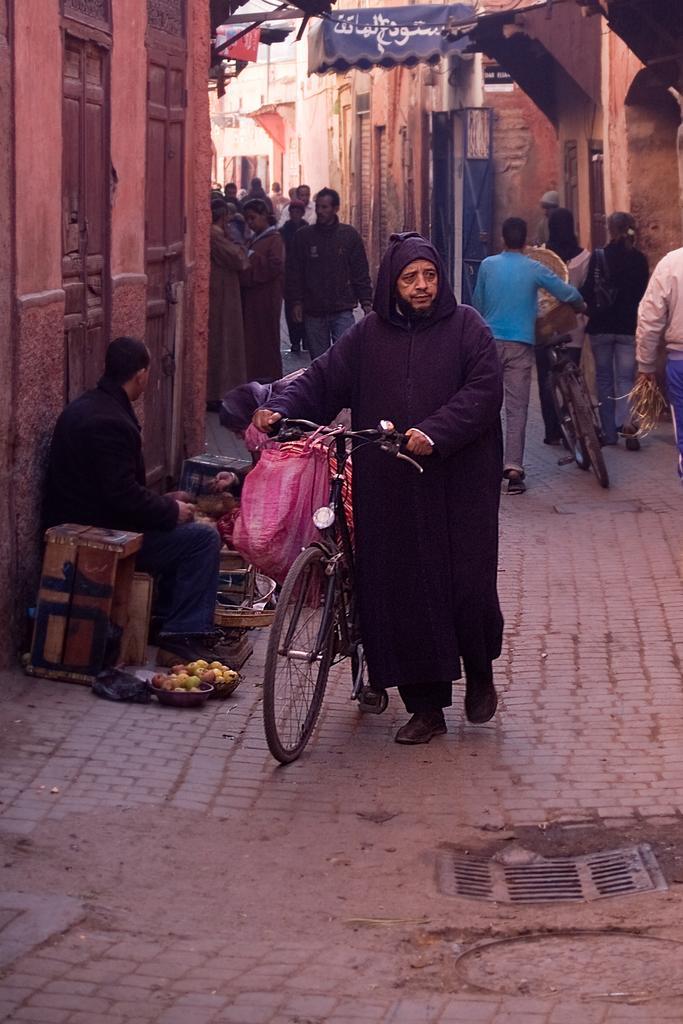In one or two sentences, can you explain what this image depicts? This picture shows a man walking along with his bicycle, holding a bag to the handle of this bicycle. There is a man sitting on the side of a road with some vegetables in the basket. In the background there are some people walking. We can observe some buildings here. 